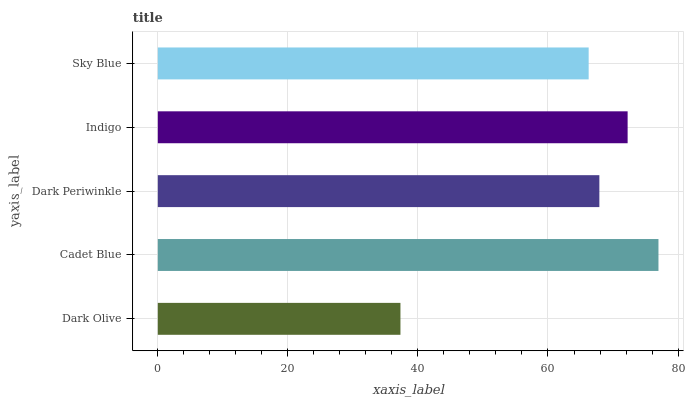Is Dark Olive the minimum?
Answer yes or no. Yes. Is Cadet Blue the maximum?
Answer yes or no. Yes. Is Dark Periwinkle the minimum?
Answer yes or no. No. Is Dark Periwinkle the maximum?
Answer yes or no. No. Is Cadet Blue greater than Dark Periwinkle?
Answer yes or no. Yes. Is Dark Periwinkle less than Cadet Blue?
Answer yes or no. Yes. Is Dark Periwinkle greater than Cadet Blue?
Answer yes or no. No. Is Cadet Blue less than Dark Periwinkle?
Answer yes or no. No. Is Dark Periwinkle the high median?
Answer yes or no. Yes. Is Dark Periwinkle the low median?
Answer yes or no. Yes. Is Sky Blue the high median?
Answer yes or no. No. Is Cadet Blue the low median?
Answer yes or no. No. 